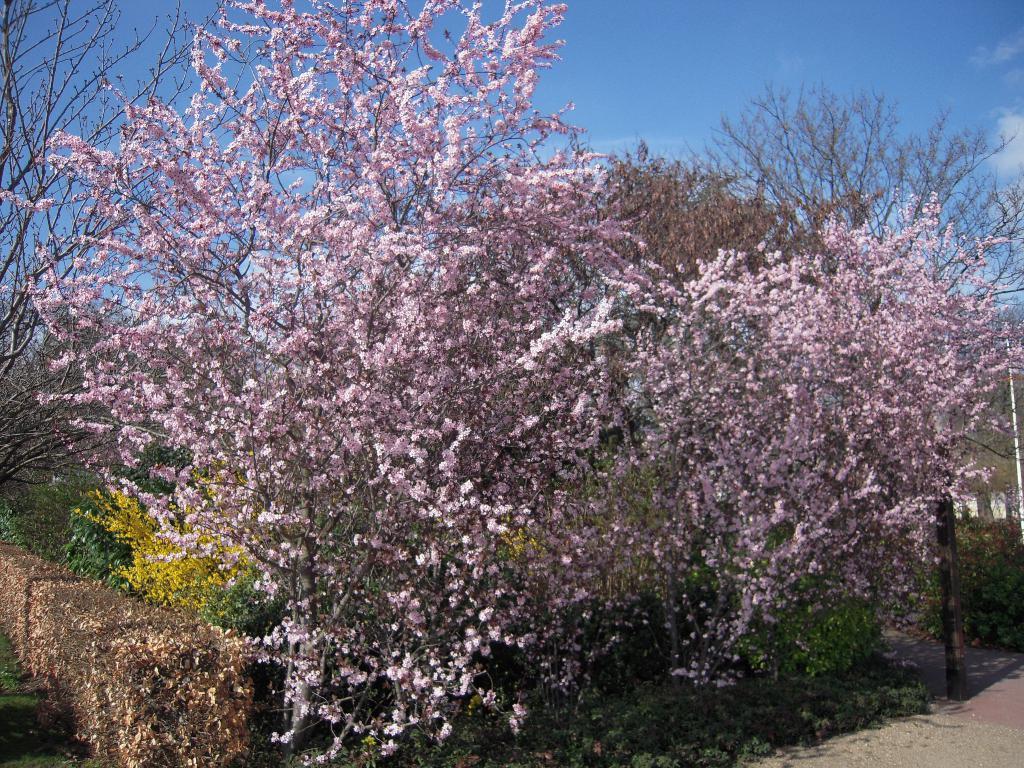Can you describe this image briefly? In this image there are trees, plants, flowers and a rod. In the background there is the sky. 